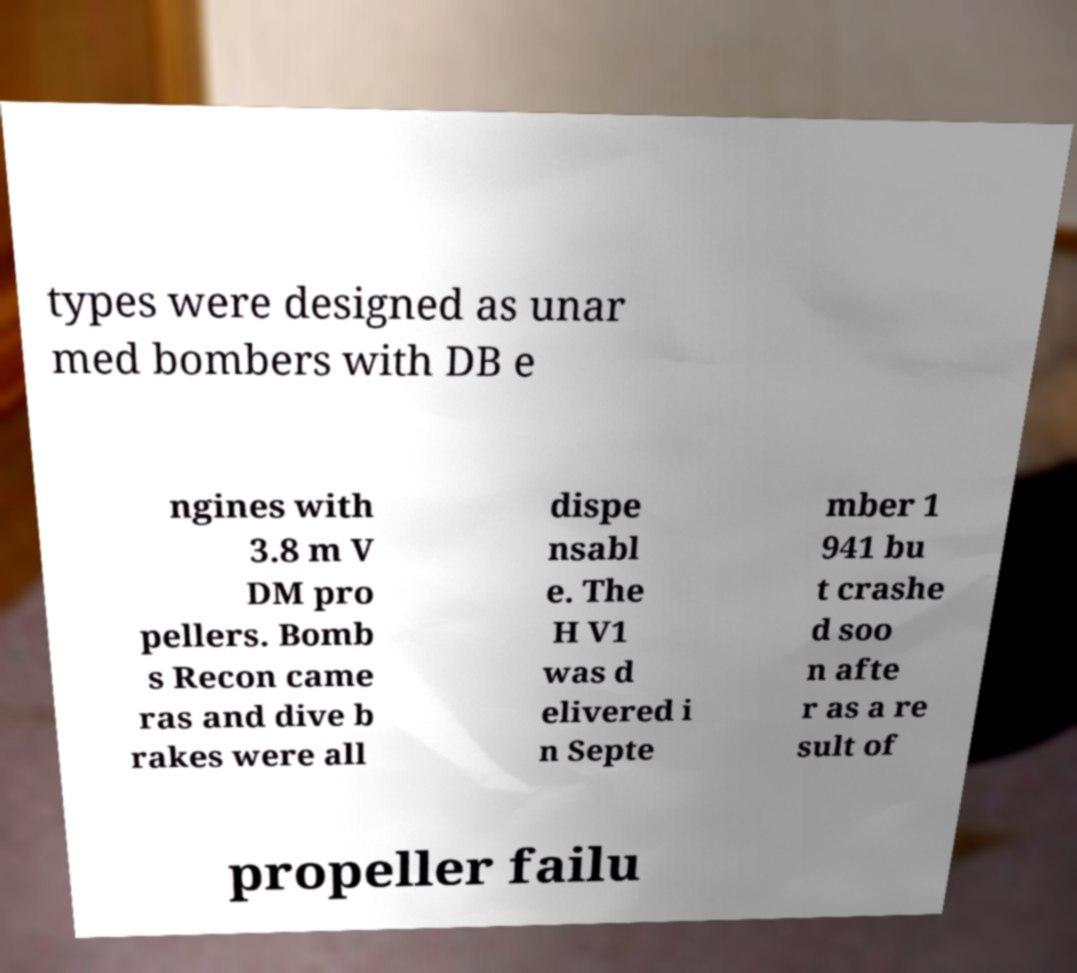Can you read and provide the text displayed in the image?This photo seems to have some interesting text. Can you extract and type it out for me? types were designed as unar med bombers with DB e ngines with 3.8 m V DM pro pellers. Bomb s Recon came ras and dive b rakes were all dispe nsabl e. The H V1 was d elivered i n Septe mber 1 941 bu t crashe d soo n afte r as a re sult of propeller failu 